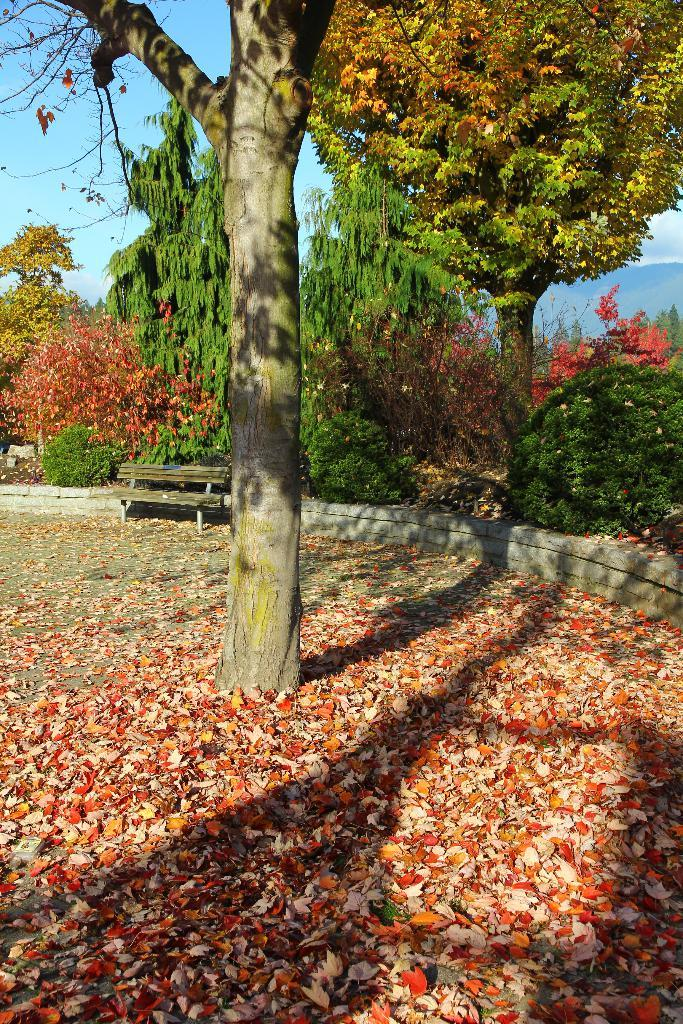What type of location is depicted in the image? There is a park in the image. What natural elements can be found in the park? The park contains trees. What type of seating is available in the park? There is a bench in the park. What can be seen on the ground in the park? The ground in the park is visible. What geographical feature can be seen in the distance? There are mountains visible in the background of the image. How does the flag adjust its position in the image? There is no flag present in the image, so it cannot be adjusted or moved. 